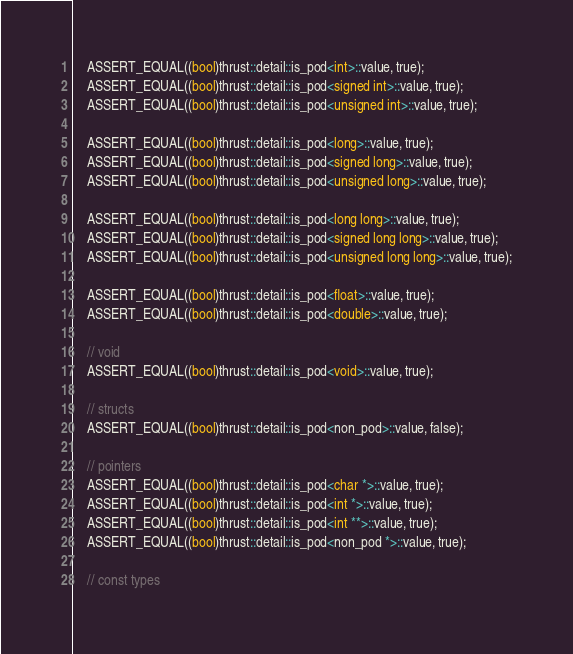<code> <loc_0><loc_0><loc_500><loc_500><_Cuda_>    ASSERT_EQUAL((bool)thrust::detail::is_pod<int>::value, true);
    ASSERT_EQUAL((bool)thrust::detail::is_pod<signed int>::value, true);
    ASSERT_EQUAL((bool)thrust::detail::is_pod<unsigned int>::value, true);
    
    ASSERT_EQUAL((bool)thrust::detail::is_pod<long>::value, true);
    ASSERT_EQUAL((bool)thrust::detail::is_pod<signed long>::value, true);
    ASSERT_EQUAL((bool)thrust::detail::is_pod<unsigned long>::value, true);
    
    ASSERT_EQUAL((bool)thrust::detail::is_pod<long long>::value, true);
    ASSERT_EQUAL((bool)thrust::detail::is_pod<signed long long>::value, true);
    ASSERT_EQUAL((bool)thrust::detail::is_pod<unsigned long long>::value, true);
    
    ASSERT_EQUAL((bool)thrust::detail::is_pod<float>::value, true);
    ASSERT_EQUAL((bool)thrust::detail::is_pod<double>::value, true);
    
    // void
    ASSERT_EQUAL((bool)thrust::detail::is_pod<void>::value, true);

    // structs
    ASSERT_EQUAL((bool)thrust::detail::is_pod<non_pod>::value, false);

    // pointers
    ASSERT_EQUAL((bool)thrust::detail::is_pod<char *>::value, true);
    ASSERT_EQUAL((bool)thrust::detail::is_pod<int *>::value, true);
    ASSERT_EQUAL((bool)thrust::detail::is_pod<int **>::value, true);
    ASSERT_EQUAL((bool)thrust::detail::is_pod<non_pod *>::value, true);

    // const types</code> 